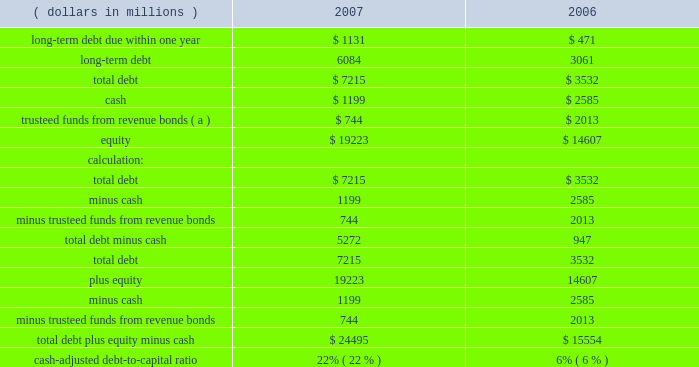Derivative instruments see quantitative and qualitative disclosures about market risk for a discussion of derivative instruments and associated market risk .
Dividends to stockholders dividends of $ 0.92 per common share or $ 637 million were paid during 2007 .
On january 27 , 2008 , our board of directors declared a dividend of $ 0.24 cents per share on our common stock , payable march 10 , 2008 , to stockholders of record at the close of business on february 20 , 2008 .
Liquidity and capital resources our main sources of liquidity and capital resources are internally generated cash flow from operations , committed credit facilities and access to both the debt and equity capital markets .
Our ability to access the debt capital market is supported by our investment grade credit ratings .
Our senior unsecured debt is currently rated investment grade by standard and poor 2019s corporation , moody 2019s investor services , inc .
And fitch ratings with ratings of bbb+ , baa1 , and bbb+ .
These ratings were reaffirmed in july 2007 after the western acquisition was announced .
Because of the alternatives available to us , including internally generated cash flow and potential asset sales , we believe that our short-term and long-term liquidity is adequate to fund operations , including our capital spending programs , stock repurchase program , repayment of debt maturities and any amounts that ultimately may be paid in connection with contingencies .
We have a committed $ 3.0 billion revolving credit facility with third-party financial institutions terminating in may 2012 .
At december 31 , 2007 , there were no borrowings against this facility and we had no commercial paper outstanding under our u.s .
Commercial paper program that is backed by this revolving credit facility .
On july 26 , 2007 , we filed a universal shelf registration statement with the securities and exchange commission , under which we , as a well-known seasoned issuer , have the ability to issue and sell an indeterminate amount of various types of debt and equity securities .
Our cash-adjusted debt-to-capital ratio ( total debt-minus-cash to total debt-plus-equity-minus-cash ) was 22 percent at december 31 , 2007 , compared to six percent at year-end 2006 as shown below .
This includes $ 498 million of debt that is serviced by united states steel .
( dollars in millions ) 2007 2006 .
( a ) following the issuance of the $ 1.0 billion of revenue bonds by the parish of st .
John the baptist , the proceeds were trusteed and will be disbursed to us upon our request for reimbursement of expenditures related to the garyville refinery expansion .
The trusteed funds are reflected as other noncurrent assets in the accompanying consolidated balance sheet as of december 31 , 2007. .
In millions , what would 2007 total debt increase to if the company fully draws its available revolver? 
Rationale: revolving credit facility - revolver
Computations: ((3.0 * 1000) + 7215)
Answer: 10215.0. 